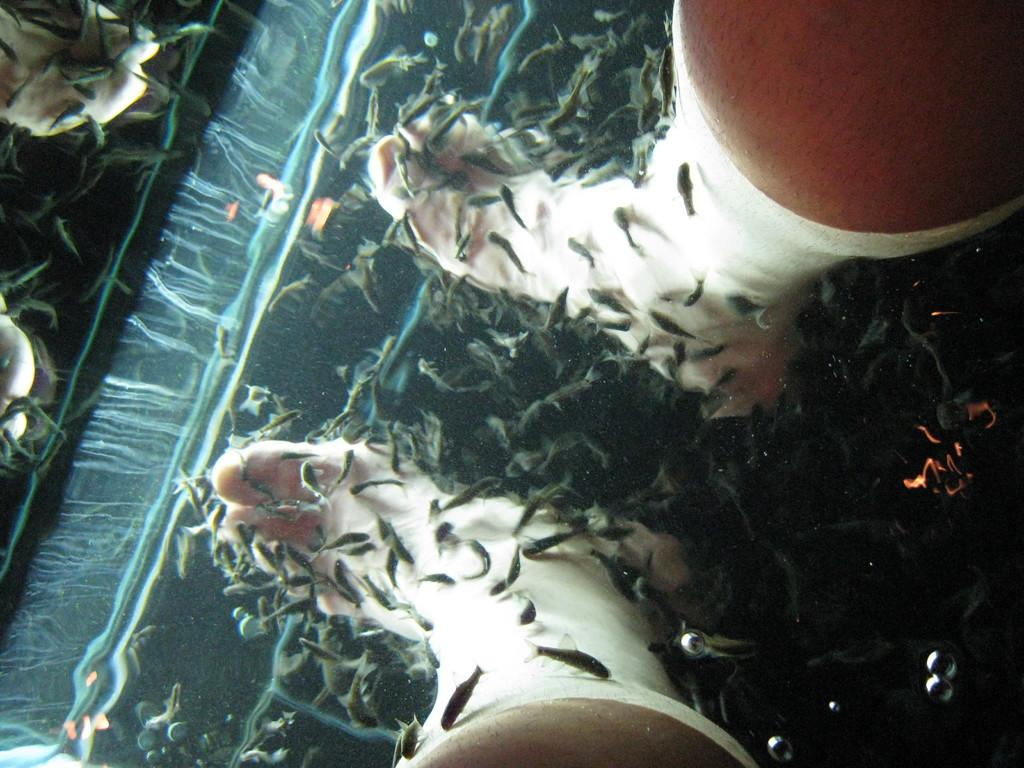What body part is visible in the image? There are legs visible in the image. What type of animal can be seen in the water in the image? There is a fish in the water in the image. What type of coach can be seen in the image? There is no coach present in the image. What beam is supporting the fish in the image? There is no beam present in the image; the fish is in the water. 